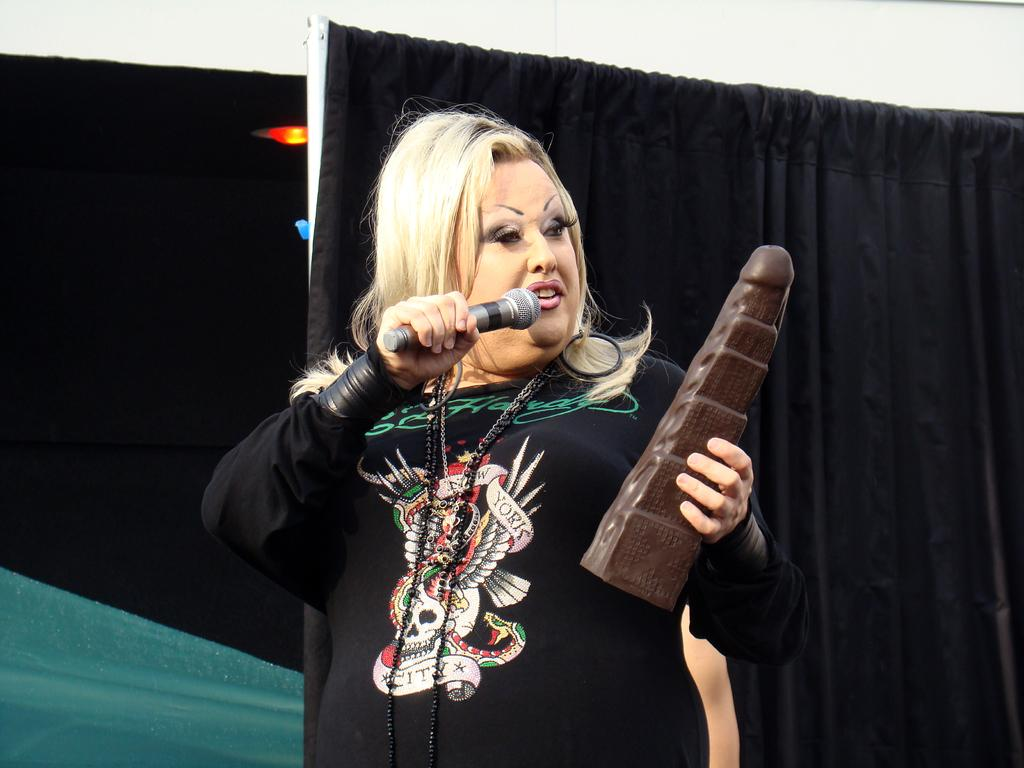Who is the main subject in the image? There is a woman in the image. What is the woman wearing? The woman is wearing a black dress. What is the woman holding in her hand? The woman is holding a mic and another object. What can be seen in the background of the image? There are black colored curtains and a white painted wall in the background. What type of punishment is being administered to the woman in the image? There is no indication of punishment in the image; the woman is holding a mic and another object. What is covering the woman's head in the image? There is no object covering the woman's head in the image; she is wearing a black dress and holding a mic. 